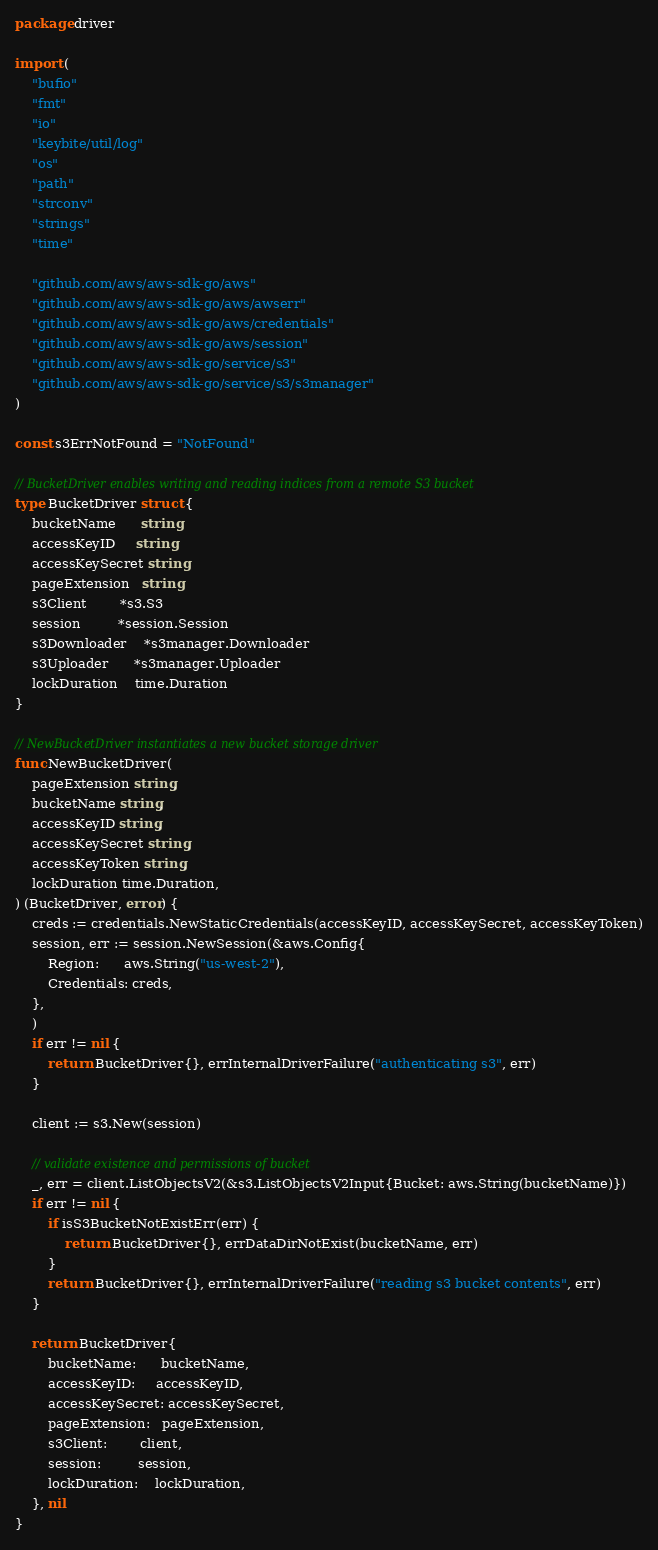<code> <loc_0><loc_0><loc_500><loc_500><_Go_>package driver

import (
	"bufio"
	"fmt"
	"io"
	"keybite/util/log"
	"os"
	"path"
	"strconv"
	"strings"
	"time"

	"github.com/aws/aws-sdk-go/aws"
	"github.com/aws/aws-sdk-go/aws/awserr"
	"github.com/aws/aws-sdk-go/aws/credentials"
	"github.com/aws/aws-sdk-go/aws/session"
	"github.com/aws/aws-sdk-go/service/s3"
	"github.com/aws/aws-sdk-go/service/s3/s3manager"
)

const s3ErrNotFound = "NotFound"

// BucketDriver enables writing and reading indices from a remote S3 bucket
type BucketDriver struct {
	bucketName      string
	accessKeyID     string
	accessKeySecret string
	pageExtension   string
	s3Client        *s3.S3
	session         *session.Session
	s3Downloader    *s3manager.Downloader
	s3Uploader      *s3manager.Uploader
	lockDuration    time.Duration
}

// NewBucketDriver instantiates a new bucket storage driver
func NewBucketDriver(
	pageExtension string,
	bucketName string,
	accessKeyID string,
	accessKeySecret string,
	accessKeyToken string,
	lockDuration time.Duration,
) (BucketDriver, error) {
	creds := credentials.NewStaticCredentials(accessKeyID, accessKeySecret, accessKeyToken)
	session, err := session.NewSession(&aws.Config{
		Region:      aws.String("us-west-2"),
		Credentials: creds,
	},
	)
	if err != nil {
		return BucketDriver{}, errInternalDriverFailure("authenticating s3", err)
	}

	client := s3.New(session)

	// validate existence and permissions of bucket
	_, err = client.ListObjectsV2(&s3.ListObjectsV2Input{Bucket: aws.String(bucketName)})
	if err != nil {
		if isS3BucketNotExistErr(err) {
			return BucketDriver{}, errDataDirNotExist(bucketName, err)
		}
		return BucketDriver{}, errInternalDriverFailure("reading s3 bucket contents", err)
	}

	return BucketDriver{
		bucketName:      bucketName,
		accessKeyID:     accessKeyID,
		accessKeySecret: accessKeySecret,
		pageExtension:   pageExtension,
		s3Client:        client,
		session:         session,
		lockDuration:    lockDuration,
	}, nil
}
</code> 